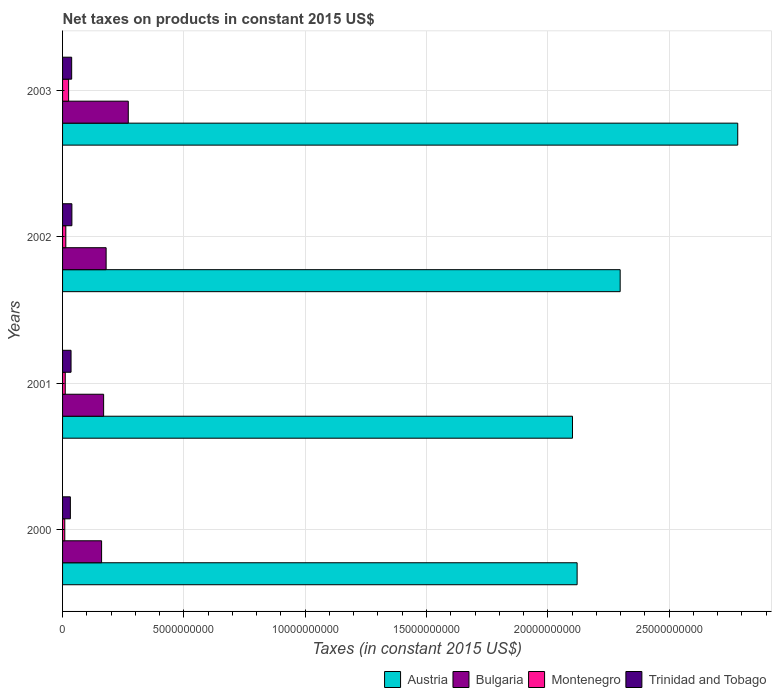Are the number of bars per tick equal to the number of legend labels?
Make the answer very short. Yes. Are the number of bars on each tick of the Y-axis equal?
Give a very brief answer. Yes. What is the label of the 1st group of bars from the top?
Keep it short and to the point. 2003. In how many cases, is the number of bars for a given year not equal to the number of legend labels?
Make the answer very short. 0. What is the net taxes on products in Austria in 2000?
Offer a very short reply. 2.12e+1. Across all years, what is the maximum net taxes on products in Montenegro?
Make the answer very short. 2.49e+08. Across all years, what is the minimum net taxes on products in Austria?
Keep it short and to the point. 2.10e+1. What is the total net taxes on products in Trinidad and Tobago in the graph?
Provide a short and direct response. 1.43e+09. What is the difference between the net taxes on products in Austria in 2001 and that in 2002?
Your answer should be compact. -1.97e+09. What is the difference between the net taxes on products in Montenegro in 2000 and the net taxes on products in Austria in 2001?
Provide a short and direct response. -2.09e+1. What is the average net taxes on products in Bulgaria per year?
Offer a terse response. 1.95e+09. In the year 2000, what is the difference between the net taxes on products in Austria and net taxes on products in Trinidad and Tobago?
Your answer should be very brief. 2.09e+1. In how many years, is the net taxes on products in Austria greater than 17000000000 US$?
Offer a very short reply. 4. What is the ratio of the net taxes on products in Bulgaria in 2000 to that in 2001?
Your answer should be compact. 0.95. Is the net taxes on products in Bulgaria in 2001 less than that in 2002?
Make the answer very short. Yes. Is the difference between the net taxes on products in Austria in 2000 and 2002 greater than the difference between the net taxes on products in Trinidad and Tobago in 2000 and 2002?
Your answer should be very brief. No. What is the difference between the highest and the second highest net taxes on products in Trinidad and Tobago?
Offer a very short reply. 8.65e+06. What is the difference between the highest and the lowest net taxes on products in Montenegro?
Make the answer very short. 1.58e+08. What does the 2nd bar from the top in 2002 represents?
Offer a very short reply. Montenegro. What does the 2nd bar from the bottom in 2002 represents?
Give a very brief answer. Bulgaria. Are all the bars in the graph horizontal?
Provide a short and direct response. Yes. How many years are there in the graph?
Your response must be concise. 4. What is the difference between two consecutive major ticks on the X-axis?
Provide a succinct answer. 5.00e+09. Are the values on the major ticks of X-axis written in scientific E-notation?
Make the answer very short. No. Does the graph contain grids?
Keep it short and to the point. Yes. How many legend labels are there?
Ensure brevity in your answer.  4. How are the legend labels stacked?
Your response must be concise. Horizontal. What is the title of the graph?
Your answer should be compact. Net taxes on products in constant 2015 US$. Does "Bermuda" appear as one of the legend labels in the graph?
Provide a succinct answer. No. What is the label or title of the X-axis?
Your answer should be compact. Taxes (in constant 2015 US$). What is the Taxes (in constant 2015 US$) of Austria in 2000?
Provide a succinct answer. 2.12e+1. What is the Taxes (in constant 2015 US$) in Bulgaria in 2000?
Keep it short and to the point. 1.61e+09. What is the Taxes (in constant 2015 US$) in Montenegro in 2000?
Your answer should be very brief. 9.12e+07. What is the Taxes (in constant 2015 US$) in Trinidad and Tobago in 2000?
Ensure brevity in your answer.  3.22e+08. What is the Taxes (in constant 2015 US$) of Austria in 2001?
Give a very brief answer. 2.10e+1. What is the Taxes (in constant 2015 US$) of Bulgaria in 2001?
Provide a short and direct response. 1.69e+09. What is the Taxes (in constant 2015 US$) of Montenegro in 2001?
Your answer should be very brief. 1.10e+08. What is the Taxes (in constant 2015 US$) of Trinidad and Tobago in 2001?
Keep it short and to the point. 3.50e+08. What is the Taxes (in constant 2015 US$) in Austria in 2002?
Make the answer very short. 2.30e+1. What is the Taxes (in constant 2015 US$) in Bulgaria in 2002?
Give a very brief answer. 1.80e+09. What is the Taxes (in constant 2015 US$) in Montenegro in 2002?
Your answer should be very brief. 1.34e+08. What is the Taxes (in constant 2015 US$) in Trinidad and Tobago in 2002?
Ensure brevity in your answer.  3.84e+08. What is the Taxes (in constant 2015 US$) in Austria in 2003?
Give a very brief answer. 2.78e+1. What is the Taxes (in constant 2015 US$) of Bulgaria in 2003?
Your answer should be compact. 2.71e+09. What is the Taxes (in constant 2015 US$) in Montenegro in 2003?
Provide a short and direct response. 2.49e+08. What is the Taxes (in constant 2015 US$) of Trinidad and Tobago in 2003?
Provide a succinct answer. 3.76e+08. Across all years, what is the maximum Taxes (in constant 2015 US$) in Austria?
Offer a very short reply. 2.78e+1. Across all years, what is the maximum Taxes (in constant 2015 US$) in Bulgaria?
Your response must be concise. 2.71e+09. Across all years, what is the maximum Taxes (in constant 2015 US$) in Montenegro?
Make the answer very short. 2.49e+08. Across all years, what is the maximum Taxes (in constant 2015 US$) in Trinidad and Tobago?
Your response must be concise. 3.84e+08. Across all years, what is the minimum Taxes (in constant 2015 US$) in Austria?
Provide a succinct answer. 2.10e+1. Across all years, what is the minimum Taxes (in constant 2015 US$) of Bulgaria?
Your response must be concise. 1.61e+09. Across all years, what is the minimum Taxes (in constant 2015 US$) in Montenegro?
Your answer should be compact. 9.12e+07. Across all years, what is the minimum Taxes (in constant 2015 US$) of Trinidad and Tobago?
Provide a succinct answer. 3.22e+08. What is the total Taxes (in constant 2015 US$) in Austria in the graph?
Ensure brevity in your answer.  9.30e+1. What is the total Taxes (in constant 2015 US$) of Bulgaria in the graph?
Your response must be concise. 7.81e+09. What is the total Taxes (in constant 2015 US$) of Montenegro in the graph?
Provide a succinct answer. 5.84e+08. What is the total Taxes (in constant 2015 US$) in Trinidad and Tobago in the graph?
Ensure brevity in your answer.  1.43e+09. What is the difference between the Taxes (in constant 2015 US$) of Austria in 2000 and that in 2001?
Ensure brevity in your answer.  1.91e+08. What is the difference between the Taxes (in constant 2015 US$) of Bulgaria in 2000 and that in 2001?
Give a very brief answer. -8.34e+07. What is the difference between the Taxes (in constant 2015 US$) in Montenegro in 2000 and that in 2001?
Provide a succinct answer. -1.92e+07. What is the difference between the Taxes (in constant 2015 US$) of Trinidad and Tobago in 2000 and that in 2001?
Offer a terse response. -2.77e+07. What is the difference between the Taxes (in constant 2015 US$) of Austria in 2000 and that in 2002?
Your response must be concise. -1.77e+09. What is the difference between the Taxes (in constant 2015 US$) in Bulgaria in 2000 and that in 2002?
Make the answer very short. -1.87e+08. What is the difference between the Taxes (in constant 2015 US$) of Montenegro in 2000 and that in 2002?
Your answer should be compact. -4.24e+07. What is the difference between the Taxes (in constant 2015 US$) of Trinidad and Tobago in 2000 and that in 2002?
Make the answer very short. -6.24e+07. What is the difference between the Taxes (in constant 2015 US$) of Austria in 2000 and that in 2003?
Ensure brevity in your answer.  -6.62e+09. What is the difference between the Taxes (in constant 2015 US$) in Bulgaria in 2000 and that in 2003?
Provide a succinct answer. -1.10e+09. What is the difference between the Taxes (in constant 2015 US$) of Montenegro in 2000 and that in 2003?
Your answer should be compact. -1.58e+08. What is the difference between the Taxes (in constant 2015 US$) of Trinidad and Tobago in 2000 and that in 2003?
Provide a short and direct response. -5.38e+07. What is the difference between the Taxes (in constant 2015 US$) of Austria in 2001 and that in 2002?
Ensure brevity in your answer.  -1.97e+09. What is the difference between the Taxes (in constant 2015 US$) in Bulgaria in 2001 and that in 2002?
Ensure brevity in your answer.  -1.03e+08. What is the difference between the Taxes (in constant 2015 US$) of Montenegro in 2001 and that in 2002?
Your answer should be very brief. -2.32e+07. What is the difference between the Taxes (in constant 2015 US$) of Trinidad and Tobago in 2001 and that in 2002?
Provide a short and direct response. -3.47e+07. What is the difference between the Taxes (in constant 2015 US$) in Austria in 2001 and that in 2003?
Ensure brevity in your answer.  -6.81e+09. What is the difference between the Taxes (in constant 2015 US$) in Bulgaria in 2001 and that in 2003?
Your answer should be compact. -1.02e+09. What is the difference between the Taxes (in constant 2015 US$) of Montenegro in 2001 and that in 2003?
Make the answer very short. -1.38e+08. What is the difference between the Taxes (in constant 2015 US$) of Trinidad and Tobago in 2001 and that in 2003?
Make the answer very short. -2.60e+07. What is the difference between the Taxes (in constant 2015 US$) of Austria in 2002 and that in 2003?
Offer a very short reply. -4.85e+09. What is the difference between the Taxes (in constant 2015 US$) of Bulgaria in 2002 and that in 2003?
Provide a succinct answer. -9.13e+08. What is the difference between the Taxes (in constant 2015 US$) of Montenegro in 2002 and that in 2003?
Keep it short and to the point. -1.15e+08. What is the difference between the Taxes (in constant 2015 US$) in Trinidad and Tobago in 2002 and that in 2003?
Ensure brevity in your answer.  8.65e+06. What is the difference between the Taxes (in constant 2015 US$) of Austria in 2000 and the Taxes (in constant 2015 US$) of Bulgaria in 2001?
Offer a terse response. 1.95e+1. What is the difference between the Taxes (in constant 2015 US$) of Austria in 2000 and the Taxes (in constant 2015 US$) of Montenegro in 2001?
Your answer should be compact. 2.11e+1. What is the difference between the Taxes (in constant 2015 US$) in Austria in 2000 and the Taxes (in constant 2015 US$) in Trinidad and Tobago in 2001?
Offer a very short reply. 2.09e+1. What is the difference between the Taxes (in constant 2015 US$) of Bulgaria in 2000 and the Taxes (in constant 2015 US$) of Montenegro in 2001?
Provide a succinct answer. 1.50e+09. What is the difference between the Taxes (in constant 2015 US$) of Bulgaria in 2000 and the Taxes (in constant 2015 US$) of Trinidad and Tobago in 2001?
Make the answer very short. 1.26e+09. What is the difference between the Taxes (in constant 2015 US$) in Montenegro in 2000 and the Taxes (in constant 2015 US$) in Trinidad and Tobago in 2001?
Offer a very short reply. -2.58e+08. What is the difference between the Taxes (in constant 2015 US$) of Austria in 2000 and the Taxes (in constant 2015 US$) of Bulgaria in 2002?
Provide a succinct answer. 1.94e+1. What is the difference between the Taxes (in constant 2015 US$) of Austria in 2000 and the Taxes (in constant 2015 US$) of Montenegro in 2002?
Ensure brevity in your answer.  2.11e+1. What is the difference between the Taxes (in constant 2015 US$) in Austria in 2000 and the Taxes (in constant 2015 US$) in Trinidad and Tobago in 2002?
Keep it short and to the point. 2.08e+1. What is the difference between the Taxes (in constant 2015 US$) in Bulgaria in 2000 and the Taxes (in constant 2015 US$) in Montenegro in 2002?
Keep it short and to the point. 1.48e+09. What is the difference between the Taxes (in constant 2015 US$) in Bulgaria in 2000 and the Taxes (in constant 2015 US$) in Trinidad and Tobago in 2002?
Your answer should be compact. 1.22e+09. What is the difference between the Taxes (in constant 2015 US$) in Montenegro in 2000 and the Taxes (in constant 2015 US$) in Trinidad and Tobago in 2002?
Give a very brief answer. -2.93e+08. What is the difference between the Taxes (in constant 2015 US$) in Austria in 2000 and the Taxes (in constant 2015 US$) in Bulgaria in 2003?
Make the answer very short. 1.85e+1. What is the difference between the Taxes (in constant 2015 US$) of Austria in 2000 and the Taxes (in constant 2015 US$) of Montenegro in 2003?
Your answer should be compact. 2.10e+1. What is the difference between the Taxes (in constant 2015 US$) of Austria in 2000 and the Taxes (in constant 2015 US$) of Trinidad and Tobago in 2003?
Offer a very short reply. 2.08e+1. What is the difference between the Taxes (in constant 2015 US$) in Bulgaria in 2000 and the Taxes (in constant 2015 US$) in Montenegro in 2003?
Your answer should be compact. 1.36e+09. What is the difference between the Taxes (in constant 2015 US$) in Bulgaria in 2000 and the Taxes (in constant 2015 US$) in Trinidad and Tobago in 2003?
Provide a short and direct response. 1.23e+09. What is the difference between the Taxes (in constant 2015 US$) of Montenegro in 2000 and the Taxes (in constant 2015 US$) of Trinidad and Tobago in 2003?
Your response must be concise. -2.84e+08. What is the difference between the Taxes (in constant 2015 US$) of Austria in 2001 and the Taxes (in constant 2015 US$) of Bulgaria in 2002?
Keep it short and to the point. 1.92e+1. What is the difference between the Taxes (in constant 2015 US$) of Austria in 2001 and the Taxes (in constant 2015 US$) of Montenegro in 2002?
Offer a terse response. 2.09e+1. What is the difference between the Taxes (in constant 2015 US$) in Austria in 2001 and the Taxes (in constant 2015 US$) in Trinidad and Tobago in 2002?
Your answer should be compact. 2.06e+1. What is the difference between the Taxes (in constant 2015 US$) of Bulgaria in 2001 and the Taxes (in constant 2015 US$) of Montenegro in 2002?
Give a very brief answer. 1.56e+09. What is the difference between the Taxes (in constant 2015 US$) in Bulgaria in 2001 and the Taxes (in constant 2015 US$) in Trinidad and Tobago in 2002?
Your response must be concise. 1.31e+09. What is the difference between the Taxes (in constant 2015 US$) of Montenegro in 2001 and the Taxes (in constant 2015 US$) of Trinidad and Tobago in 2002?
Keep it short and to the point. -2.74e+08. What is the difference between the Taxes (in constant 2015 US$) in Austria in 2001 and the Taxes (in constant 2015 US$) in Bulgaria in 2003?
Offer a very short reply. 1.83e+1. What is the difference between the Taxes (in constant 2015 US$) in Austria in 2001 and the Taxes (in constant 2015 US$) in Montenegro in 2003?
Your response must be concise. 2.08e+1. What is the difference between the Taxes (in constant 2015 US$) in Austria in 2001 and the Taxes (in constant 2015 US$) in Trinidad and Tobago in 2003?
Keep it short and to the point. 2.06e+1. What is the difference between the Taxes (in constant 2015 US$) of Bulgaria in 2001 and the Taxes (in constant 2015 US$) of Montenegro in 2003?
Offer a very short reply. 1.44e+09. What is the difference between the Taxes (in constant 2015 US$) in Bulgaria in 2001 and the Taxes (in constant 2015 US$) in Trinidad and Tobago in 2003?
Your answer should be compact. 1.32e+09. What is the difference between the Taxes (in constant 2015 US$) in Montenegro in 2001 and the Taxes (in constant 2015 US$) in Trinidad and Tobago in 2003?
Ensure brevity in your answer.  -2.65e+08. What is the difference between the Taxes (in constant 2015 US$) of Austria in 2002 and the Taxes (in constant 2015 US$) of Bulgaria in 2003?
Offer a terse response. 2.03e+1. What is the difference between the Taxes (in constant 2015 US$) in Austria in 2002 and the Taxes (in constant 2015 US$) in Montenegro in 2003?
Offer a terse response. 2.27e+1. What is the difference between the Taxes (in constant 2015 US$) of Austria in 2002 and the Taxes (in constant 2015 US$) of Trinidad and Tobago in 2003?
Give a very brief answer. 2.26e+1. What is the difference between the Taxes (in constant 2015 US$) in Bulgaria in 2002 and the Taxes (in constant 2015 US$) in Montenegro in 2003?
Offer a very short reply. 1.55e+09. What is the difference between the Taxes (in constant 2015 US$) of Bulgaria in 2002 and the Taxes (in constant 2015 US$) of Trinidad and Tobago in 2003?
Your answer should be very brief. 1.42e+09. What is the difference between the Taxes (in constant 2015 US$) of Montenegro in 2002 and the Taxes (in constant 2015 US$) of Trinidad and Tobago in 2003?
Provide a succinct answer. -2.42e+08. What is the average Taxes (in constant 2015 US$) in Austria per year?
Your answer should be very brief. 2.33e+1. What is the average Taxes (in constant 2015 US$) of Bulgaria per year?
Provide a succinct answer. 1.95e+09. What is the average Taxes (in constant 2015 US$) in Montenegro per year?
Your answer should be very brief. 1.46e+08. What is the average Taxes (in constant 2015 US$) in Trinidad and Tobago per year?
Offer a terse response. 3.58e+08. In the year 2000, what is the difference between the Taxes (in constant 2015 US$) in Austria and Taxes (in constant 2015 US$) in Bulgaria?
Your answer should be compact. 1.96e+1. In the year 2000, what is the difference between the Taxes (in constant 2015 US$) of Austria and Taxes (in constant 2015 US$) of Montenegro?
Keep it short and to the point. 2.11e+1. In the year 2000, what is the difference between the Taxes (in constant 2015 US$) in Austria and Taxes (in constant 2015 US$) in Trinidad and Tobago?
Provide a short and direct response. 2.09e+1. In the year 2000, what is the difference between the Taxes (in constant 2015 US$) in Bulgaria and Taxes (in constant 2015 US$) in Montenegro?
Make the answer very short. 1.52e+09. In the year 2000, what is the difference between the Taxes (in constant 2015 US$) in Bulgaria and Taxes (in constant 2015 US$) in Trinidad and Tobago?
Provide a short and direct response. 1.29e+09. In the year 2000, what is the difference between the Taxes (in constant 2015 US$) of Montenegro and Taxes (in constant 2015 US$) of Trinidad and Tobago?
Offer a very short reply. -2.31e+08. In the year 2001, what is the difference between the Taxes (in constant 2015 US$) in Austria and Taxes (in constant 2015 US$) in Bulgaria?
Keep it short and to the point. 1.93e+1. In the year 2001, what is the difference between the Taxes (in constant 2015 US$) in Austria and Taxes (in constant 2015 US$) in Montenegro?
Your answer should be compact. 2.09e+1. In the year 2001, what is the difference between the Taxes (in constant 2015 US$) in Austria and Taxes (in constant 2015 US$) in Trinidad and Tobago?
Your response must be concise. 2.07e+1. In the year 2001, what is the difference between the Taxes (in constant 2015 US$) in Bulgaria and Taxes (in constant 2015 US$) in Montenegro?
Offer a terse response. 1.58e+09. In the year 2001, what is the difference between the Taxes (in constant 2015 US$) in Bulgaria and Taxes (in constant 2015 US$) in Trinidad and Tobago?
Give a very brief answer. 1.34e+09. In the year 2001, what is the difference between the Taxes (in constant 2015 US$) in Montenegro and Taxes (in constant 2015 US$) in Trinidad and Tobago?
Give a very brief answer. -2.39e+08. In the year 2002, what is the difference between the Taxes (in constant 2015 US$) in Austria and Taxes (in constant 2015 US$) in Bulgaria?
Your answer should be compact. 2.12e+1. In the year 2002, what is the difference between the Taxes (in constant 2015 US$) of Austria and Taxes (in constant 2015 US$) of Montenegro?
Offer a very short reply. 2.28e+1. In the year 2002, what is the difference between the Taxes (in constant 2015 US$) in Austria and Taxes (in constant 2015 US$) in Trinidad and Tobago?
Keep it short and to the point. 2.26e+1. In the year 2002, what is the difference between the Taxes (in constant 2015 US$) in Bulgaria and Taxes (in constant 2015 US$) in Montenegro?
Offer a terse response. 1.66e+09. In the year 2002, what is the difference between the Taxes (in constant 2015 US$) of Bulgaria and Taxes (in constant 2015 US$) of Trinidad and Tobago?
Ensure brevity in your answer.  1.41e+09. In the year 2002, what is the difference between the Taxes (in constant 2015 US$) in Montenegro and Taxes (in constant 2015 US$) in Trinidad and Tobago?
Provide a succinct answer. -2.51e+08. In the year 2003, what is the difference between the Taxes (in constant 2015 US$) in Austria and Taxes (in constant 2015 US$) in Bulgaria?
Offer a very short reply. 2.51e+1. In the year 2003, what is the difference between the Taxes (in constant 2015 US$) in Austria and Taxes (in constant 2015 US$) in Montenegro?
Ensure brevity in your answer.  2.76e+1. In the year 2003, what is the difference between the Taxes (in constant 2015 US$) in Austria and Taxes (in constant 2015 US$) in Trinidad and Tobago?
Provide a short and direct response. 2.75e+1. In the year 2003, what is the difference between the Taxes (in constant 2015 US$) in Bulgaria and Taxes (in constant 2015 US$) in Montenegro?
Your response must be concise. 2.46e+09. In the year 2003, what is the difference between the Taxes (in constant 2015 US$) in Bulgaria and Taxes (in constant 2015 US$) in Trinidad and Tobago?
Ensure brevity in your answer.  2.33e+09. In the year 2003, what is the difference between the Taxes (in constant 2015 US$) in Montenegro and Taxes (in constant 2015 US$) in Trinidad and Tobago?
Give a very brief answer. -1.27e+08. What is the ratio of the Taxes (in constant 2015 US$) of Austria in 2000 to that in 2001?
Offer a very short reply. 1.01. What is the ratio of the Taxes (in constant 2015 US$) of Bulgaria in 2000 to that in 2001?
Ensure brevity in your answer.  0.95. What is the ratio of the Taxes (in constant 2015 US$) of Montenegro in 2000 to that in 2001?
Your answer should be compact. 0.83. What is the ratio of the Taxes (in constant 2015 US$) in Trinidad and Tobago in 2000 to that in 2001?
Provide a short and direct response. 0.92. What is the ratio of the Taxes (in constant 2015 US$) in Austria in 2000 to that in 2002?
Your answer should be compact. 0.92. What is the ratio of the Taxes (in constant 2015 US$) of Bulgaria in 2000 to that in 2002?
Offer a very short reply. 0.9. What is the ratio of the Taxes (in constant 2015 US$) of Montenegro in 2000 to that in 2002?
Your answer should be very brief. 0.68. What is the ratio of the Taxes (in constant 2015 US$) of Trinidad and Tobago in 2000 to that in 2002?
Provide a succinct answer. 0.84. What is the ratio of the Taxes (in constant 2015 US$) of Austria in 2000 to that in 2003?
Provide a short and direct response. 0.76. What is the ratio of the Taxes (in constant 2015 US$) of Bulgaria in 2000 to that in 2003?
Provide a short and direct response. 0.59. What is the ratio of the Taxes (in constant 2015 US$) of Montenegro in 2000 to that in 2003?
Offer a terse response. 0.37. What is the ratio of the Taxes (in constant 2015 US$) in Trinidad and Tobago in 2000 to that in 2003?
Your answer should be compact. 0.86. What is the ratio of the Taxes (in constant 2015 US$) of Austria in 2001 to that in 2002?
Your answer should be compact. 0.91. What is the ratio of the Taxes (in constant 2015 US$) of Bulgaria in 2001 to that in 2002?
Your response must be concise. 0.94. What is the ratio of the Taxes (in constant 2015 US$) of Montenegro in 2001 to that in 2002?
Make the answer very short. 0.83. What is the ratio of the Taxes (in constant 2015 US$) of Trinidad and Tobago in 2001 to that in 2002?
Ensure brevity in your answer.  0.91. What is the ratio of the Taxes (in constant 2015 US$) in Austria in 2001 to that in 2003?
Ensure brevity in your answer.  0.76. What is the ratio of the Taxes (in constant 2015 US$) in Bulgaria in 2001 to that in 2003?
Keep it short and to the point. 0.62. What is the ratio of the Taxes (in constant 2015 US$) of Montenegro in 2001 to that in 2003?
Offer a terse response. 0.44. What is the ratio of the Taxes (in constant 2015 US$) in Trinidad and Tobago in 2001 to that in 2003?
Give a very brief answer. 0.93. What is the ratio of the Taxes (in constant 2015 US$) of Austria in 2002 to that in 2003?
Your answer should be compact. 0.83. What is the ratio of the Taxes (in constant 2015 US$) of Bulgaria in 2002 to that in 2003?
Make the answer very short. 0.66. What is the ratio of the Taxes (in constant 2015 US$) of Montenegro in 2002 to that in 2003?
Your response must be concise. 0.54. What is the ratio of the Taxes (in constant 2015 US$) in Trinidad and Tobago in 2002 to that in 2003?
Offer a very short reply. 1.02. What is the difference between the highest and the second highest Taxes (in constant 2015 US$) of Austria?
Give a very brief answer. 4.85e+09. What is the difference between the highest and the second highest Taxes (in constant 2015 US$) in Bulgaria?
Offer a very short reply. 9.13e+08. What is the difference between the highest and the second highest Taxes (in constant 2015 US$) in Montenegro?
Your answer should be very brief. 1.15e+08. What is the difference between the highest and the second highest Taxes (in constant 2015 US$) of Trinidad and Tobago?
Make the answer very short. 8.65e+06. What is the difference between the highest and the lowest Taxes (in constant 2015 US$) in Austria?
Make the answer very short. 6.81e+09. What is the difference between the highest and the lowest Taxes (in constant 2015 US$) in Bulgaria?
Offer a very short reply. 1.10e+09. What is the difference between the highest and the lowest Taxes (in constant 2015 US$) of Montenegro?
Your answer should be compact. 1.58e+08. What is the difference between the highest and the lowest Taxes (in constant 2015 US$) in Trinidad and Tobago?
Offer a very short reply. 6.24e+07. 